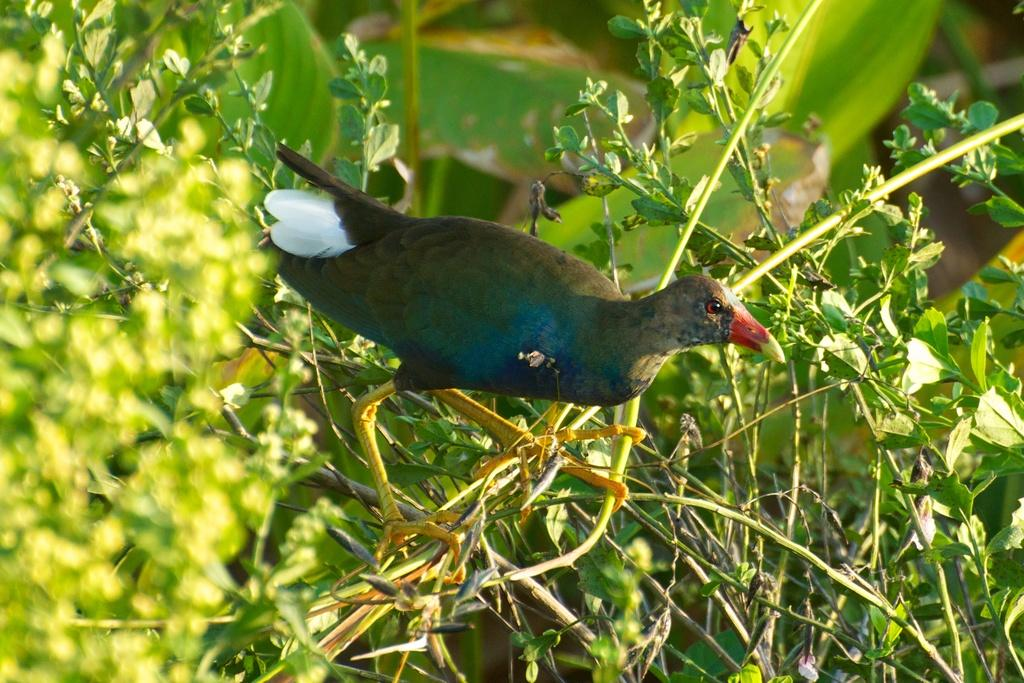What is the main subject in the center of the image? There is a bird in the center of the image. What can be seen in the background of the image? There are plants in the background of the image. Are there any specific details about the plants visible in the image? Leaves are visible in the image. What type of hair can be seen on the bird in the image? Birds do not have hair, so there is no hair visible on the bird in the image. 